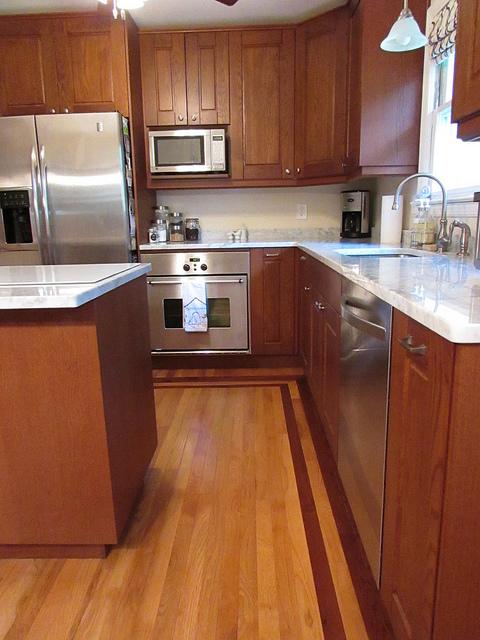Is this kitchen clean?
Quick response, please. Yes. What color are the countertops?
Write a very short answer. White. Where is the dishwasher?
Quick response, please. By sink. Does the fridge make ice?
Concise answer only. Yes. 